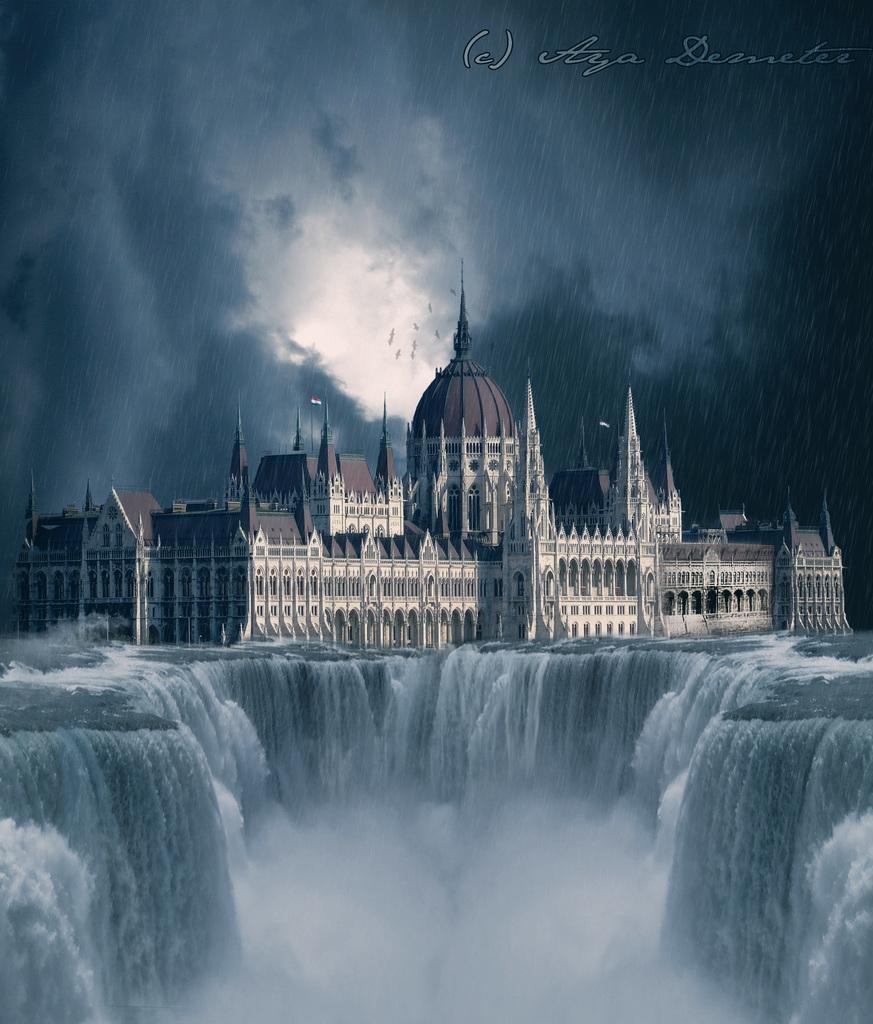In one or two sentences, can you explain what this image depicts? This is an animated image. In the image there is a waterfall. And also there is a building. At the top of the image there is sky with clouds. And it is raining in the image. In the top right corner of the image there is some text. 